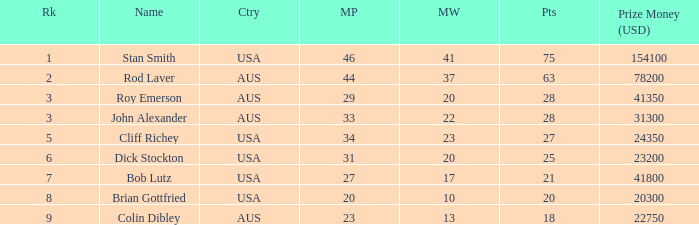How much prize money (in usd) did bob lutz win 41800.0. 